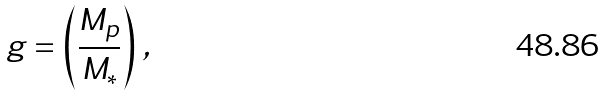<formula> <loc_0><loc_0><loc_500><loc_500>g = \left ( \frac { M _ { p } } { M _ { \ast } } \right ) \, ,</formula> 